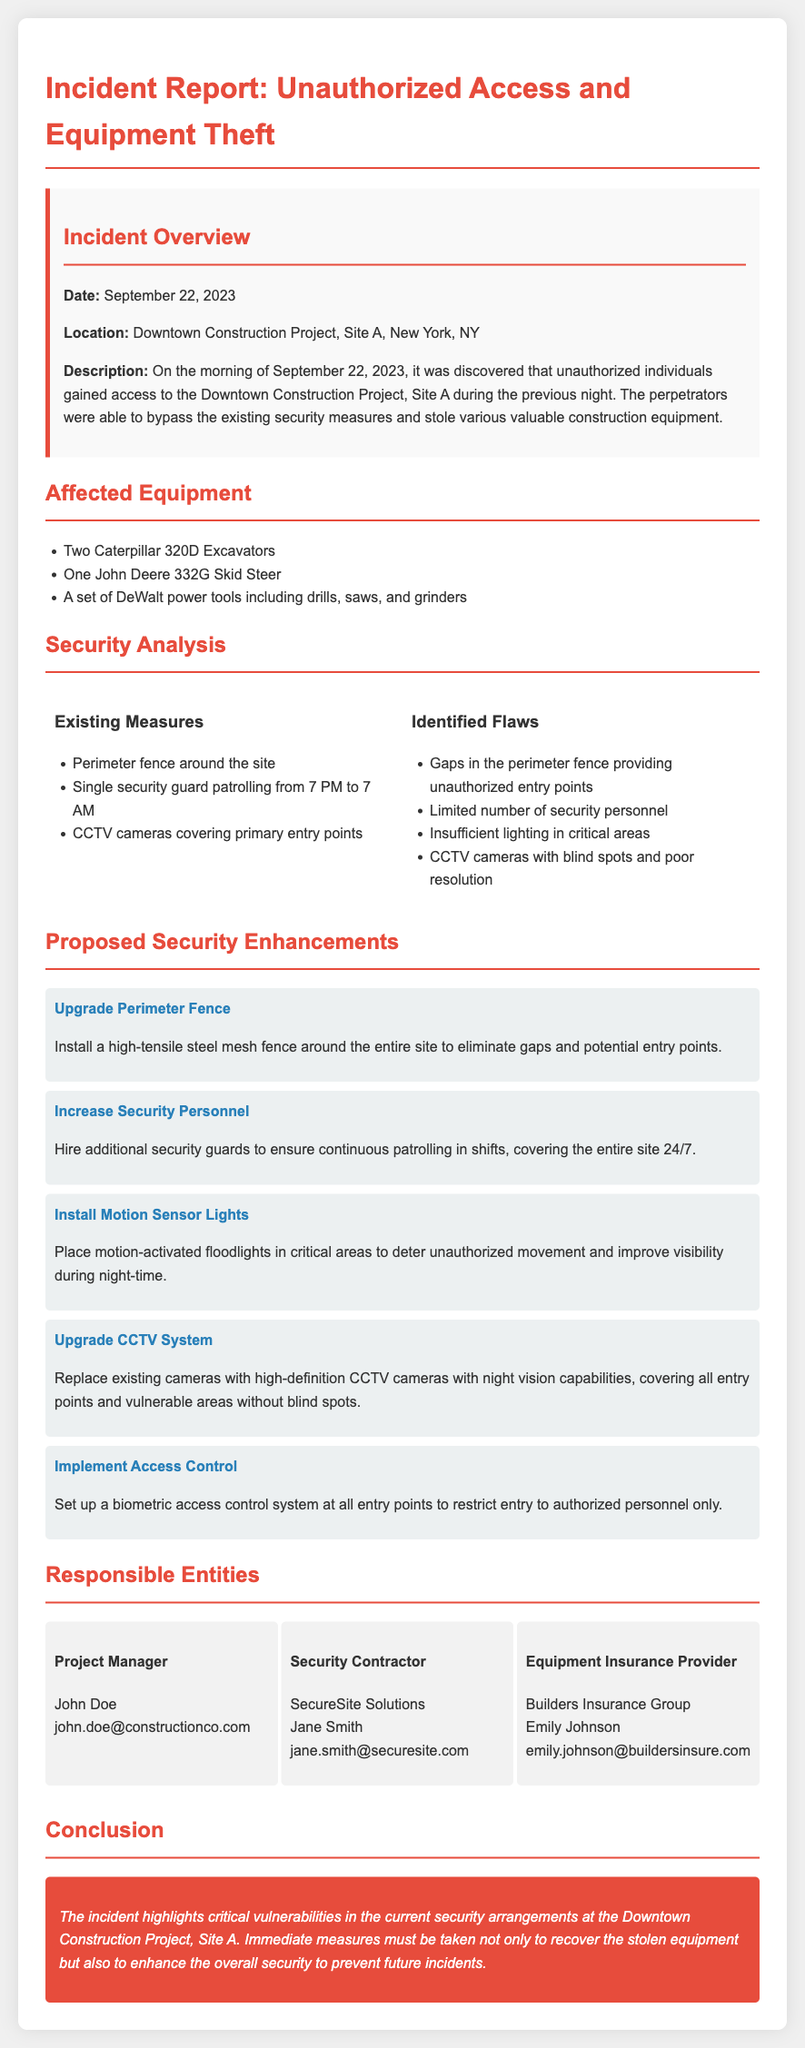What date did the incident occur? The date of the incident is explicitly mentioned in the document as September 22, 2023.
Answer: September 22, 2023 Where did the unauthorized access occur? The location of the unauthorized access is stated in the document as Downtown Construction Project, Site A, New York, NY.
Answer: Downtown Construction Project, Site A, New York, NY How many excavators were stolen? The document lists two specific Caterpillar excavators among the affected equipment, indicating the amount stolen.
Answer: Two What is one identified flaw in the existing security measures? The document contains a list of flaws; one example given is gaps in the perimeter fence providing unauthorized entry points.
Answer: Gaps in the perimeter fence What is one proposed security enhancement? The document provides several proposed enhancements, one of which is to upgrade the perimeter fence.
Answer: Upgrade Perimeter Fence Who is the project manager? The document states the project manager's name and email, defining who is responsible for overseeing the incident response.
Answer: John Doe What is the main conclusion of the report? The conclusion summarizes critical vulnerabilities in security, emphasizing the need for immediate action to recover stolen equipment and enhance security.
Answer: Immediate measures must be taken not only to recover the stolen equipment but also to enhance the overall security to prevent future incidents How many types of equipment were listed as stolen? The document specifies three distinct items in the list of affected equipment, which provides the required count.
Answer: Three 